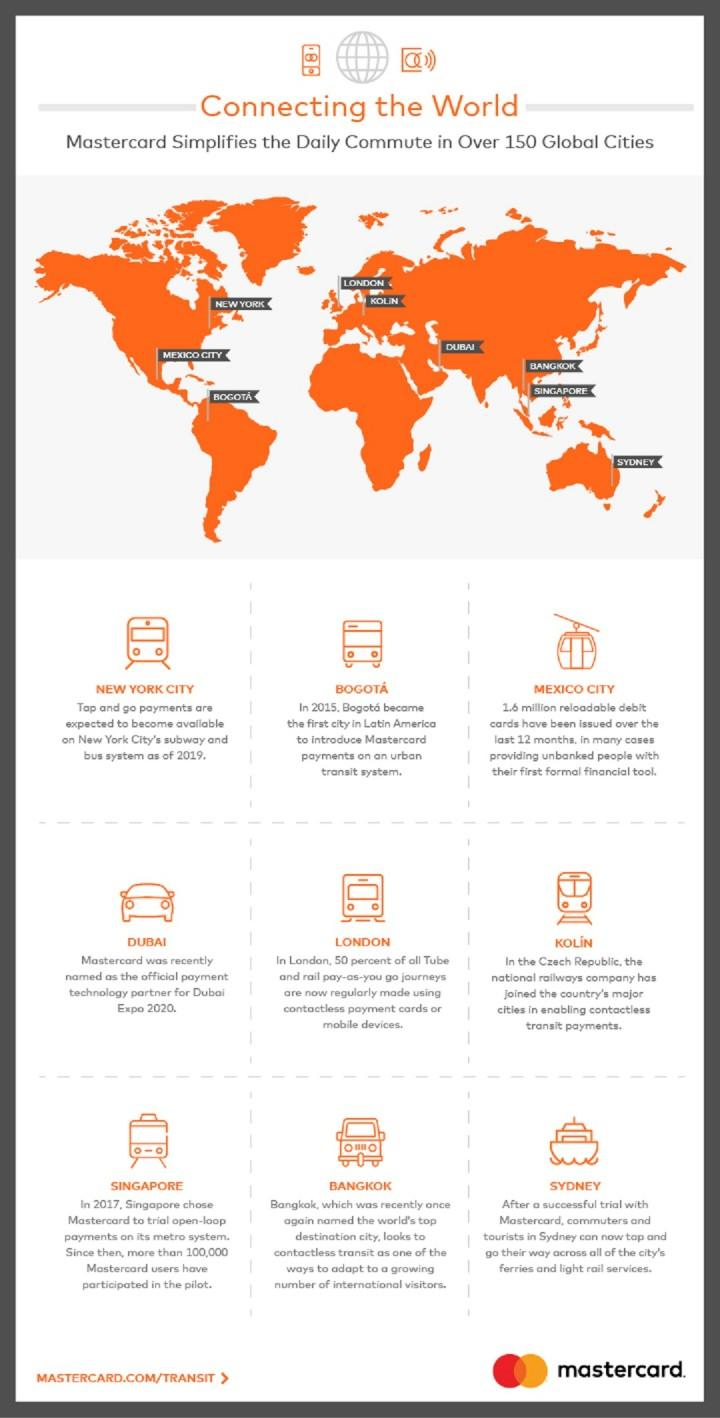Give some essential details in this illustration. In Sydney, the use of Mastercards is available in every ferry and light rail service. The major town in the Czech Republic that offers contactless transit payment options is Kolin. Bogota was the first city to use MasterCard in its transit system. According to recent rankings, Bangkok has been named the world's top destination city. The city depicted on the map located in the rightmost corner is an island and is Sydney. 